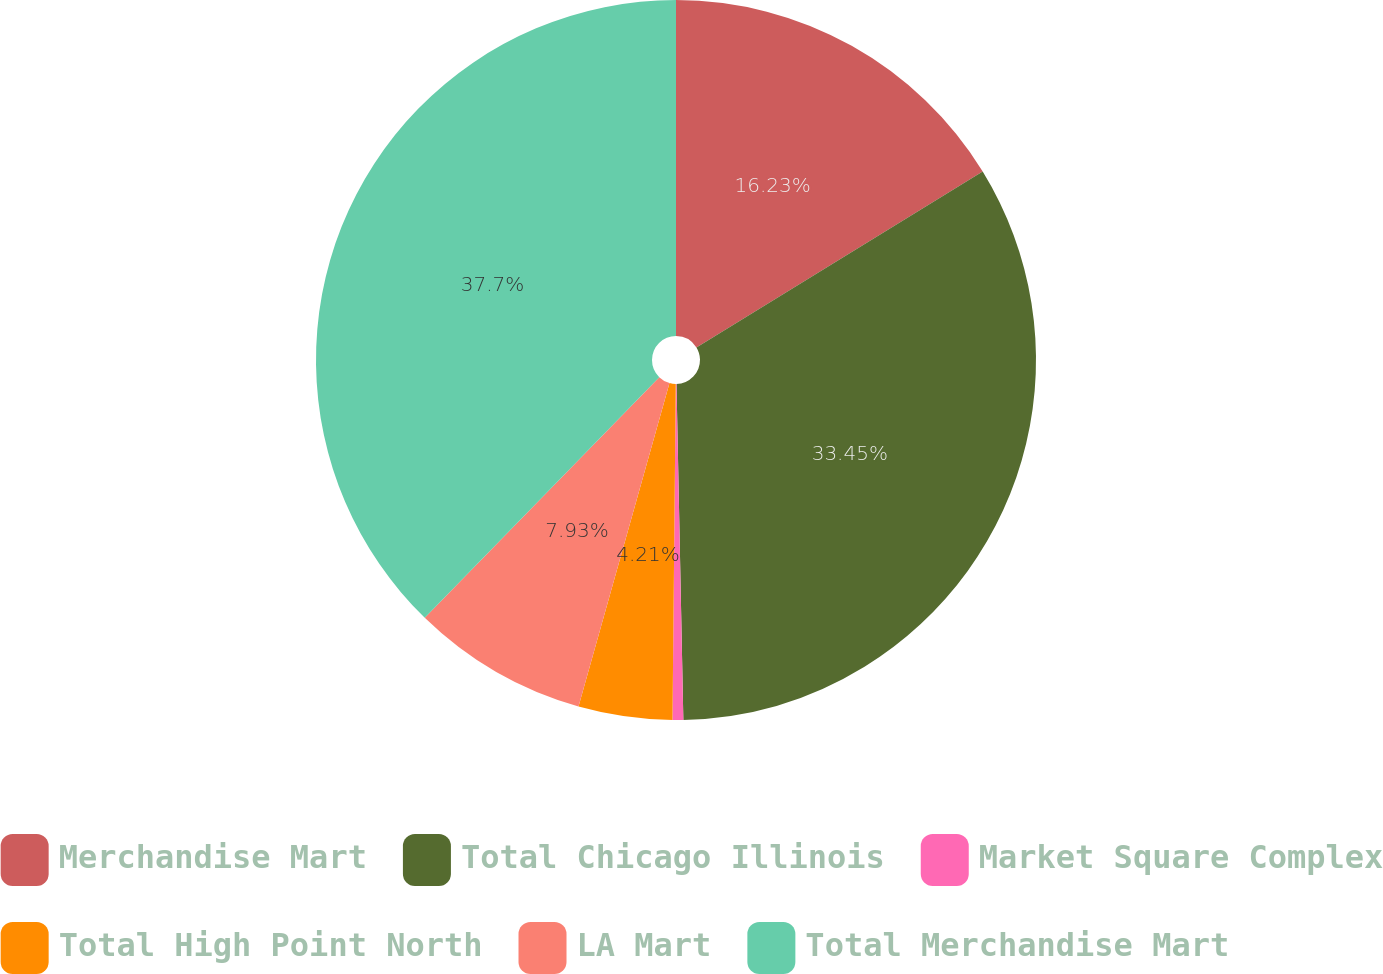<chart> <loc_0><loc_0><loc_500><loc_500><pie_chart><fcel>Merchandise Mart<fcel>Total Chicago Illinois<fcel>Market Square Complex<fcel>Total High Point North<fcel>LA Mart<fcel>Total Merchandise Mart<nl><fcel>16.23%<fcel>33.45%<fcel>0.48%<fcel>4.21%<fcel>7.93%<fcel>37.71%<nl></chart> 